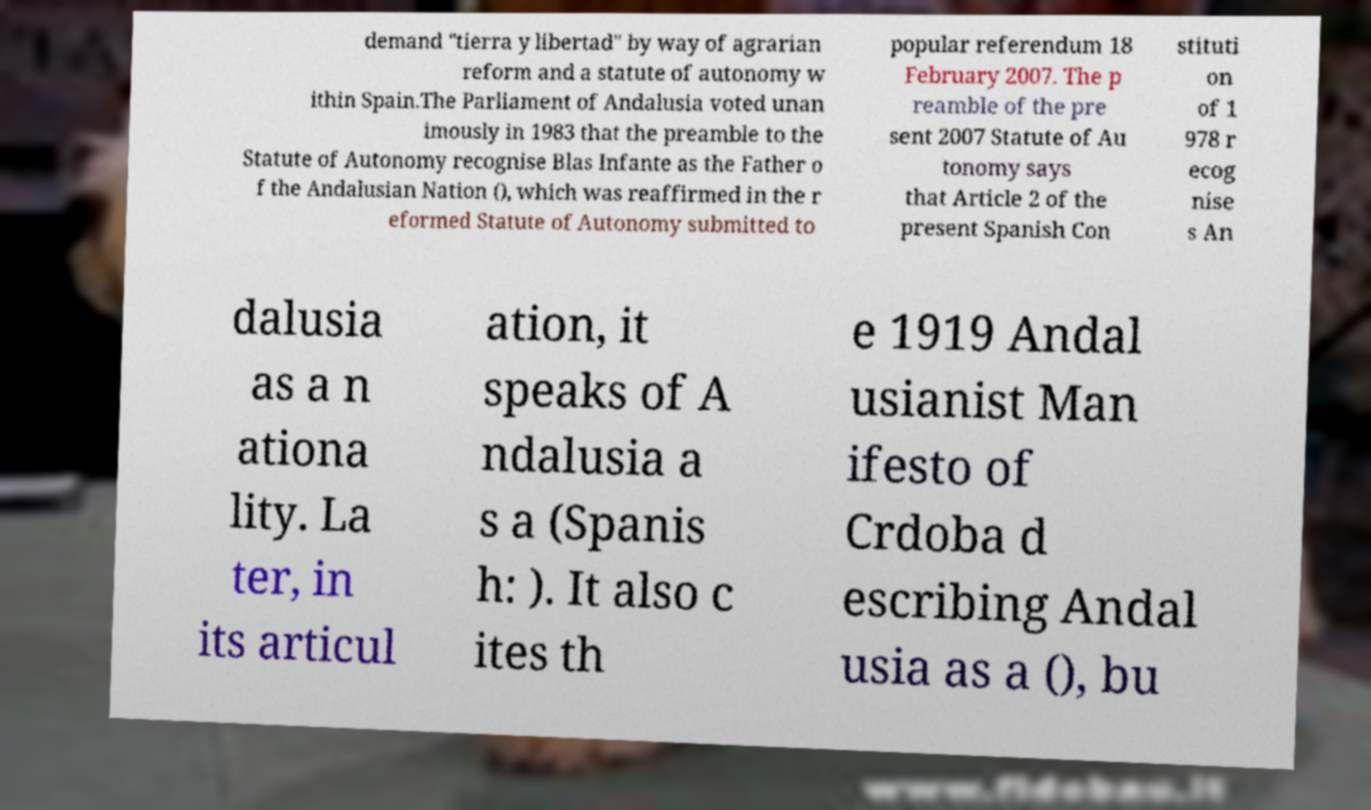Can you accurately transcribe the text from the provided image for me? demand "tierra y libertad" by way of agrarian reform and a statute of autonomy w ithin Spain.The Parliament of Andalusia voted unan imously in 1983 that the preamble to the Statute of Autonomy recognise Blas Infante as the Father o f the Andalusian Nation (), which was reaffirmed in the r eformed Statute of Autonomy submitted to popular referendum 18 February 2007. The p reamble of the pre sent 2007 Statute of Au tonomy says that Article 2 of the present Spanish Con stituti on of 1 978 r ecog nise s An dalusia as a n ationa lity. La ter, in its articul ation, it speaks of A ndalusia a s a (Spanis h: ). It also c ites th e 1919 Andal usianist Man ifesto of Crdoba d escribing Andal usia as a (), bu 